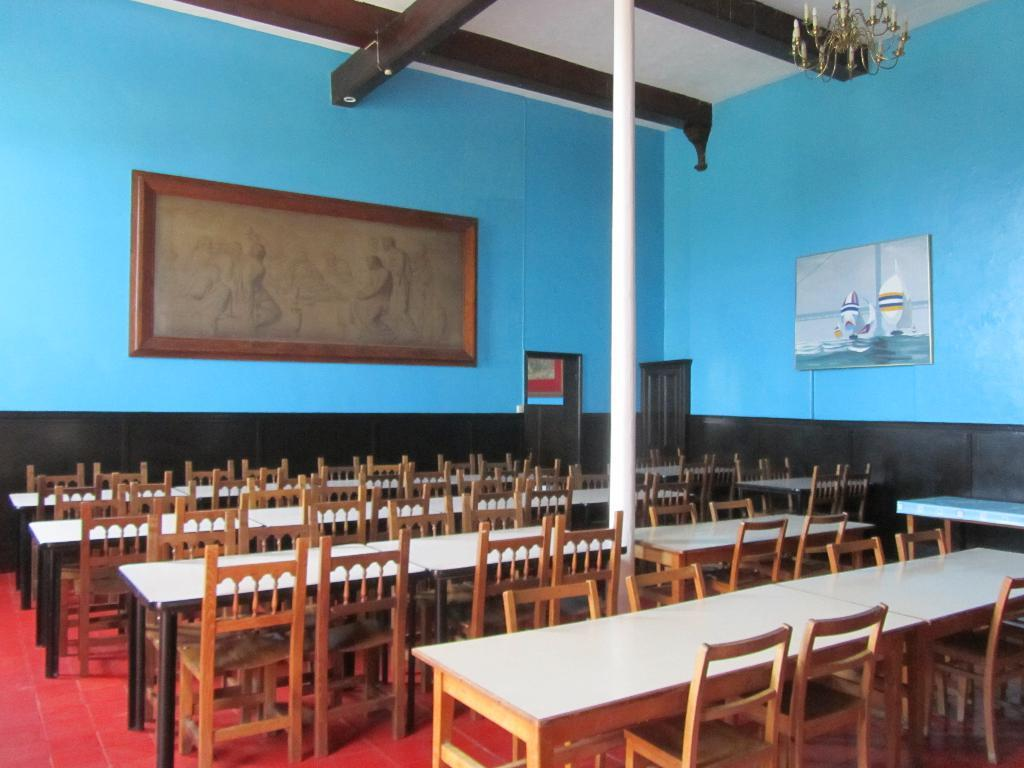What type of space is shown in the image? The image is an inside picture of a room. What furniture is present in the room? There are chairs and tables in the room. What decorative items can be seen on the wall? There are photo frames on the wall. What type of lighting fixture is visible in the room? There is a chandelier visible at the top of the room. What additional feature is present in the room? There is a pole in the room. Can you hear the baby crying in the image? There is no baby present in the image, so it is not possible to hear a baby crying. 